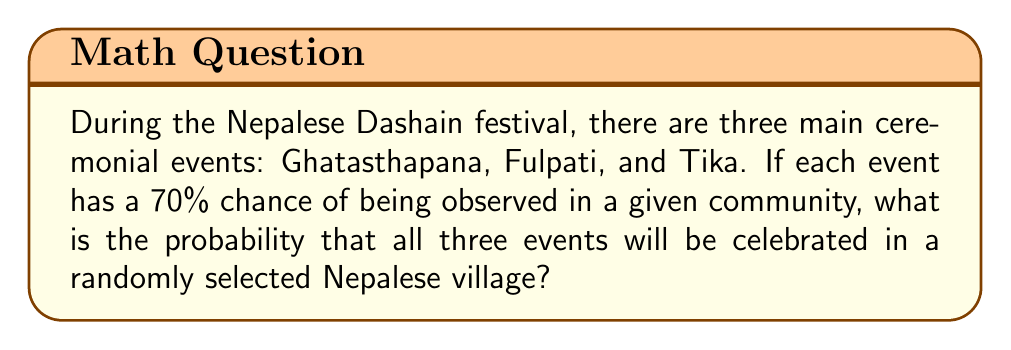Give your solution to this math problem. To solve this problem, we need to use the concept of independent events and probability multiplication.

Step 1: Identify the probability of each event occurring.
P(Ghatasthapana) = 0.70
P(Fulpati) = 0.70
P(Tika) = 0.70

Step 2: Since we want the probability of all three events occurring, we need to multiply the individual probabilities.

P(All three events) = P(Ghatasthapana) × P(Fulpati) × P(Tika)

Step 3: Substitute the values and calculate.
P(All three events) = 0.70 × 0.70 × 0.70

Step 4: Perform the multiplication.
P(All three events) = 0.343

Step 5: Convert to a percentage.
P(All three events) = 0.343 × 100% = 34.3%

Therefore, the probability that all three ceremonial events (Ghatasthapana, Fulpati, and Tika) will be celebrated in a randomly selected Nepalese village during the Dashain festival is approximately 34.3%.
Answer: $0.343$ or $34.3\%$ 